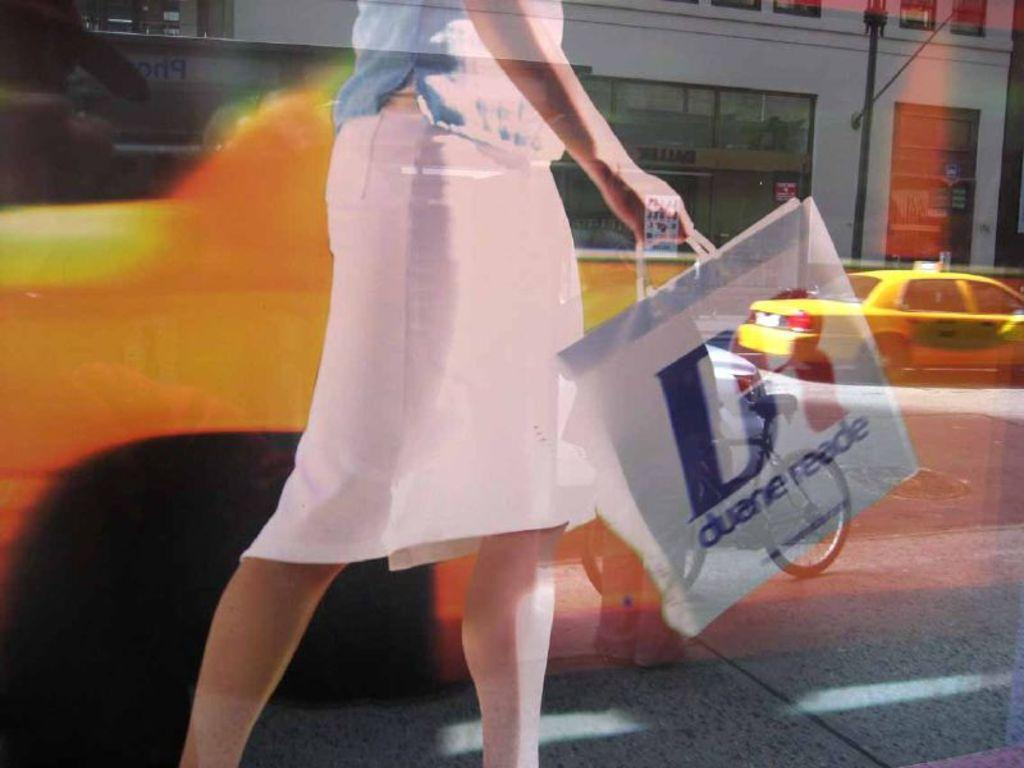<image>
Share a concise interpretation of the image provided. A woman in a pink skirt swinging a shopping bag from Duane Reade. 